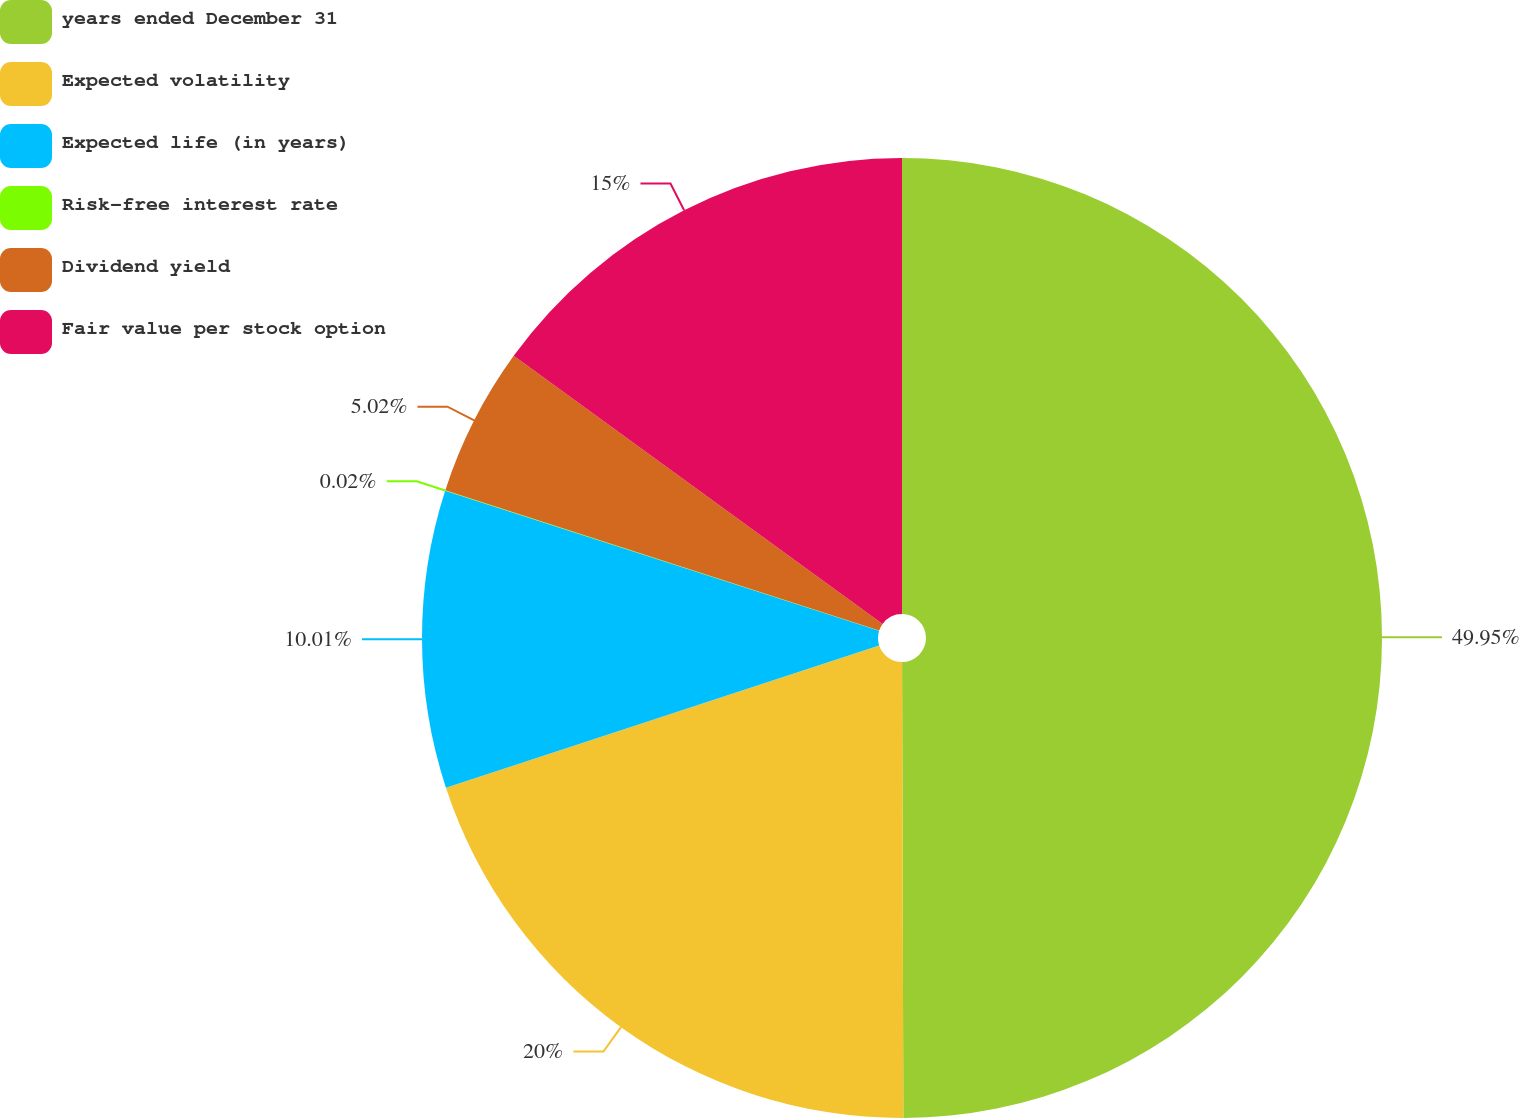Convert chart to OTSL. <chart><loc_0><loc_0><loc_500><loc_500><pie_chart><fcel>years ended December 31<fcel>Expected volatility<fcel>Expected life (in years)<fcel>Risk-free interest rate<fcel>Dividend yield<fcel>Fair value per stock option<nl><fcel>49.96%<fcel>20.0%<fcel>10.01%<fcel>0.02%<fcel>5.02%<fcel>15.0%<nl></chart> 